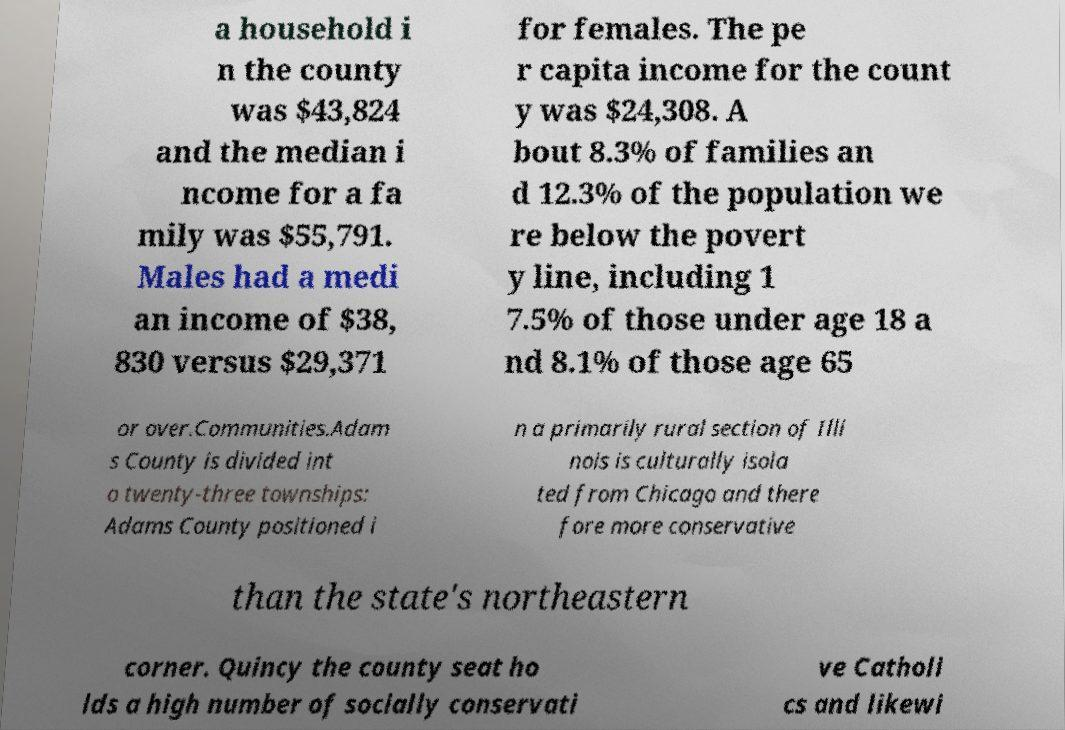Please identify and transcribe the text found in this image. a household i n the county was $43,824 and the median i ncome for a fa mily was $55,791. Males had a medi an income of $38, 830 versus $29,371 for females. The pe r capita income for the count y was $24,308. A bout 8.3% of families an d 12.3% of the population we re below the povert y line, including 1 7.5% of those under age 18 a nd 8.1% of those age 65 or over.Communities.Adam s County is divided int o twenty-three townships: Adams County positioned i n a primarily rural section of Illi nois is culturally isola ted from Chicago and there fore more conservative than the state's northeastern corner. Quincy the county seat ho lds a high number of socially conservati ve Catholi cs and likewi 